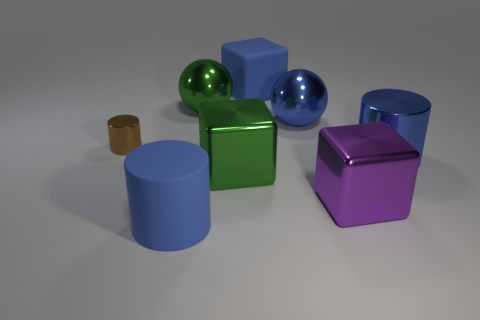Subtract all purple balls. How many blue cylinders are left? 2 Subtract all blue matte cylinders. How many cylinders are left? 2 Subtract 1 cylinders. How many cylinders are left? 2 Add 1 large purple rubber things. How many objects exist? 9 Subtract all yellow cubes. Subtract all purple balls. How many cubes are left? 3 Subtract all blocks. How many objects are left? 5 Add 5 blue cylinders. How many blue cylinders exist? 7 Subtract 0 cyan cubes. How many objects are left? 8 Subtract all tiny red rubber objects. Subtract all big blue matte things. How many objects are left? 6 Add 4 purple metallic objects. How many purple metallic objects are left? 5 